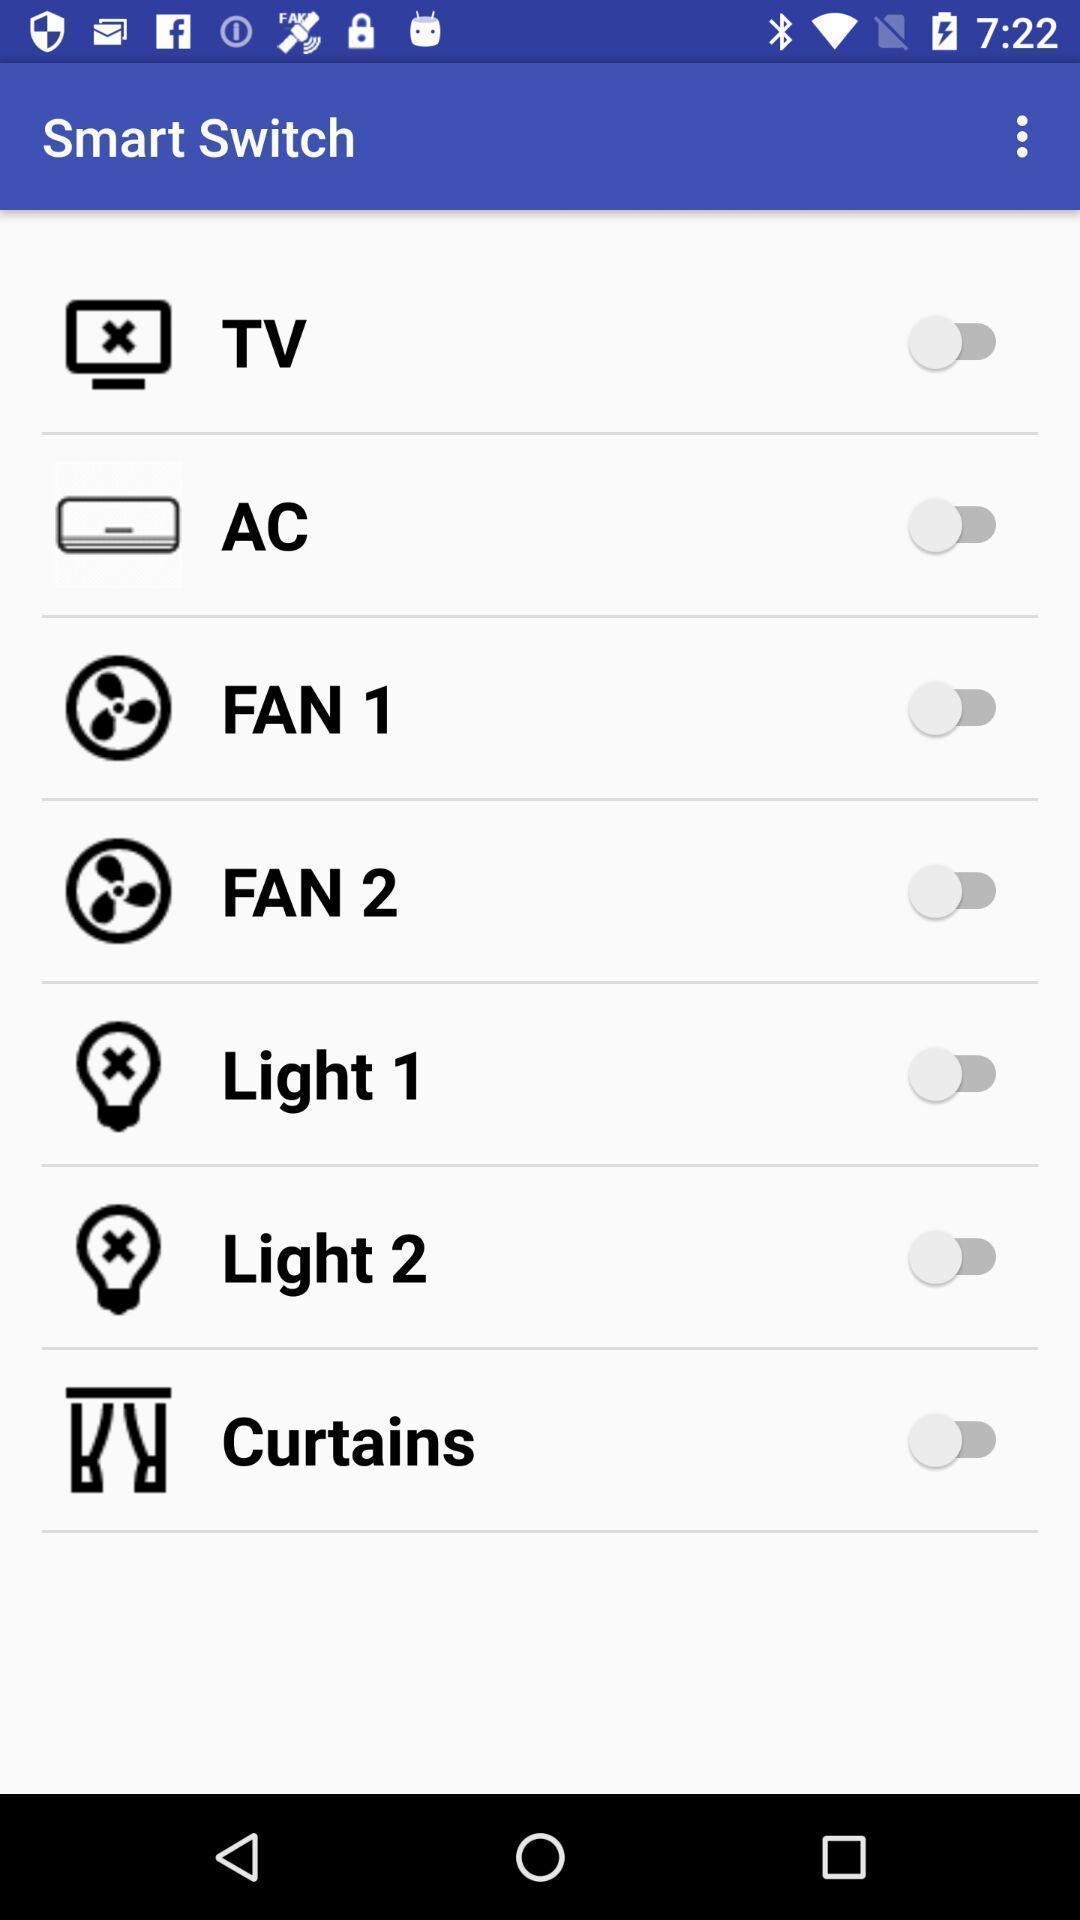Describe the visual elements of this screenshot. Screen shows different smart switch options. 